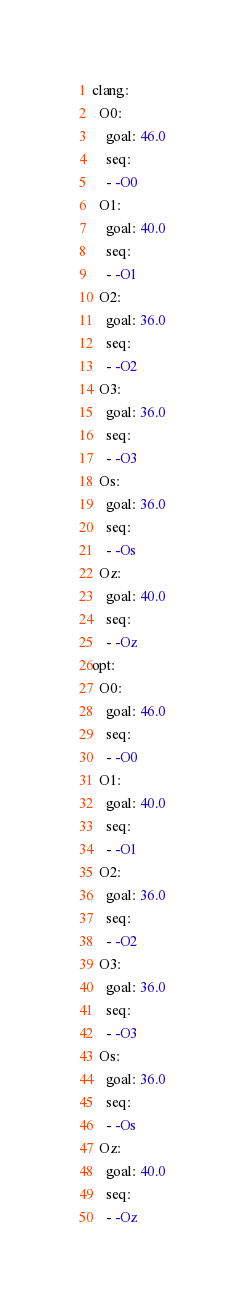<code> <loc_0><loc_0><loc_500><loc_500><_YAML_>clang:
  O0:
    goal: 46.0
    seq:
    - -O0
  O1:
    goal: 40.0
    seq:
    - -O1
  O2:
    goal: 36.0
    seq:
    - -O2
  O3:
    goal: 36.0
    seq:
    - -O3
  Os:
    goal: 36.0
    seq:
    - -Os
  Oz:
    goal: 40.0
    seq:
    - -Oz
opt:
  O0:
    goal: 46.0
    seq:
    - -O0
  O1:
    goal: 40.0
    seq:
    - -O1
  O2:
    goal: 36.0
    seq:
    - -O2
  O3:
    goal: 36.0
    seq:
    - -O3
  Os:
    goal: 36.0
    seq:
    - -Os
  Oz:
    goal: 40.0
    seq:
    - -Oz
</code> 